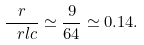<formula> <loc_0><loc_0><loc_500><loc_500>\frac { r } { \ r l c } \simeq \frac { 9 } { 6 4 } \simeq 0 . 1 4 .</formula> 